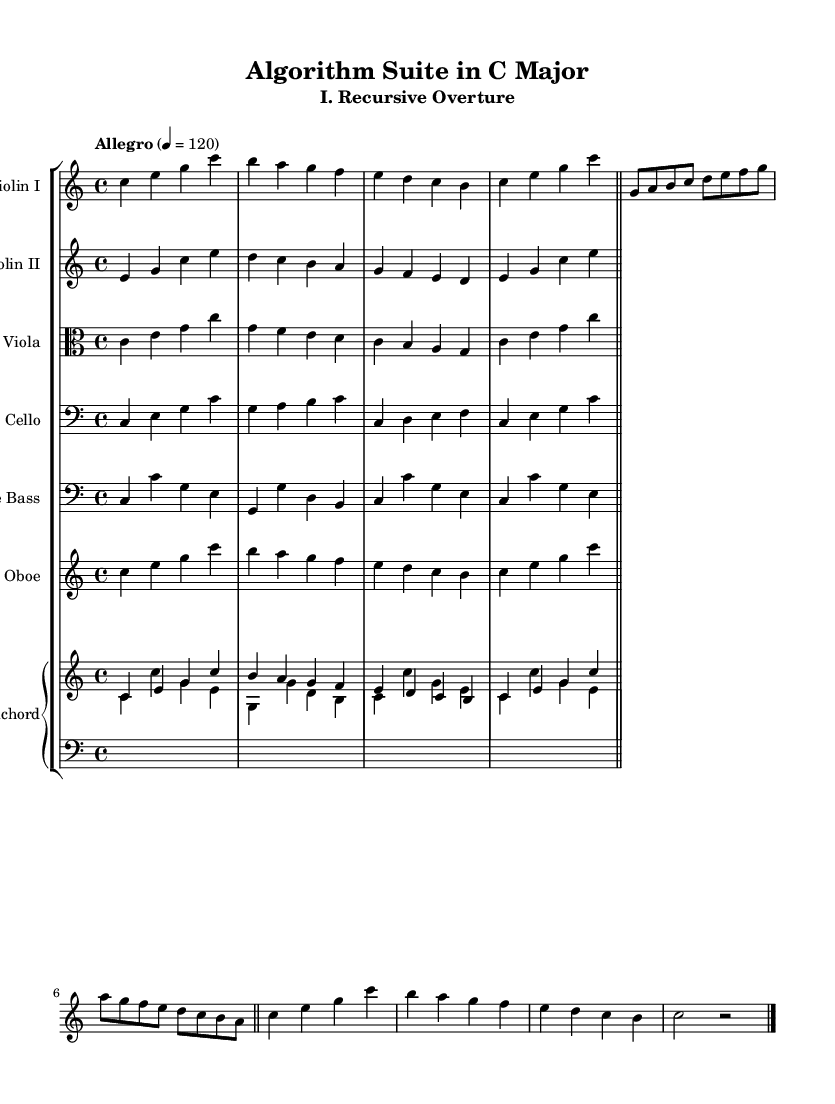What is the key signature of this music? The key signature is C major, which has no sharps or flats.
Answer: C major What is the time signature of this music? The time signature appears at the beginning and indicates four beats per measure, represented as 4/4.
Answer: 4/4 What is the tempo marking of this piece? The tempo marking above the music suggests the piece should be played at a lively speed of 120 beats per minute.
Answer: Allegro 4 = 120 How many sections are present in this piece? The piece is structured into three main sections: Exposition, Development, and Recapitulation, indicated by clear thematic variations.
Answer: Three Which instrument plays the bass line primarily? The double bass is indicated as the instrument that supports the harmonic foundation throughout the piece, particularly in the lower register.
Answer: Double bass What style is this music primarily associated with? The composition uses both counterpoint and ornamentation, characteristic of the Baroque style, which often includes intricate melodic lines and harmonic structures.
Answer: Baroque In what way does this piece mimic a computer algorithm? The arrangement features structured repetition and variation, akin to algorithmic processes where sequences are repeated and manipulated, reflecting computational logic in music.
Answer: Structured repetition 